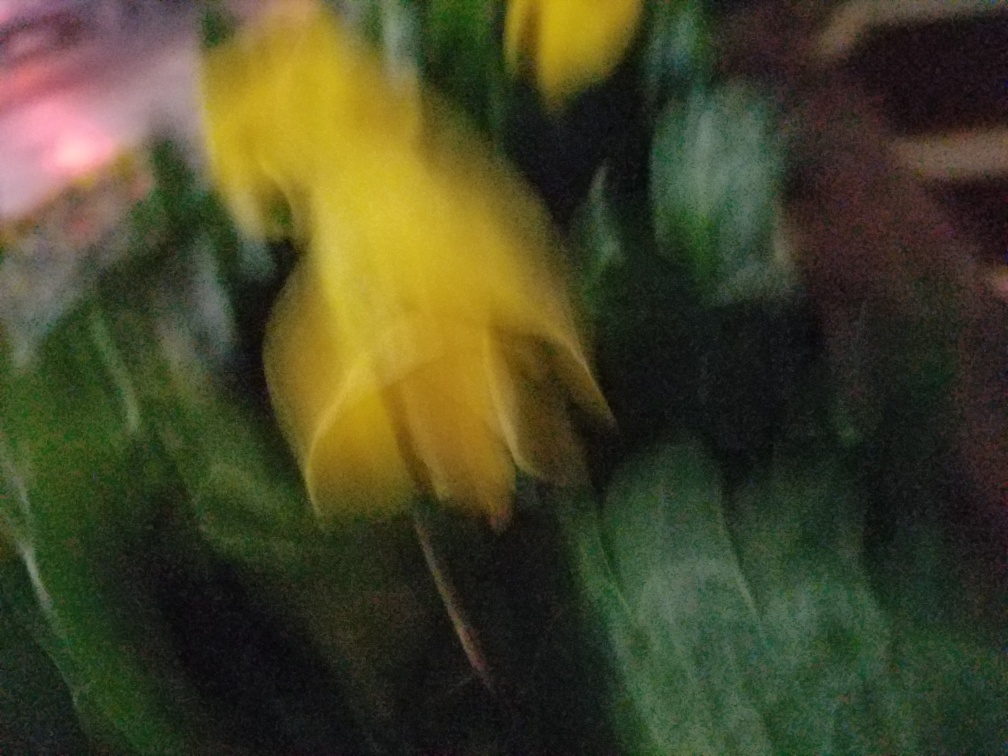Considering the photo's poor quality, what elements suggest that it was taken in a natural setting? Despite the poor quality, the hints of green and yellow suggest natural elements, such as plants or flowers. The soft, diffused forms in the background could imply that this photo was taken outdoors, possibly in a garden or a park where such colors are typical. 